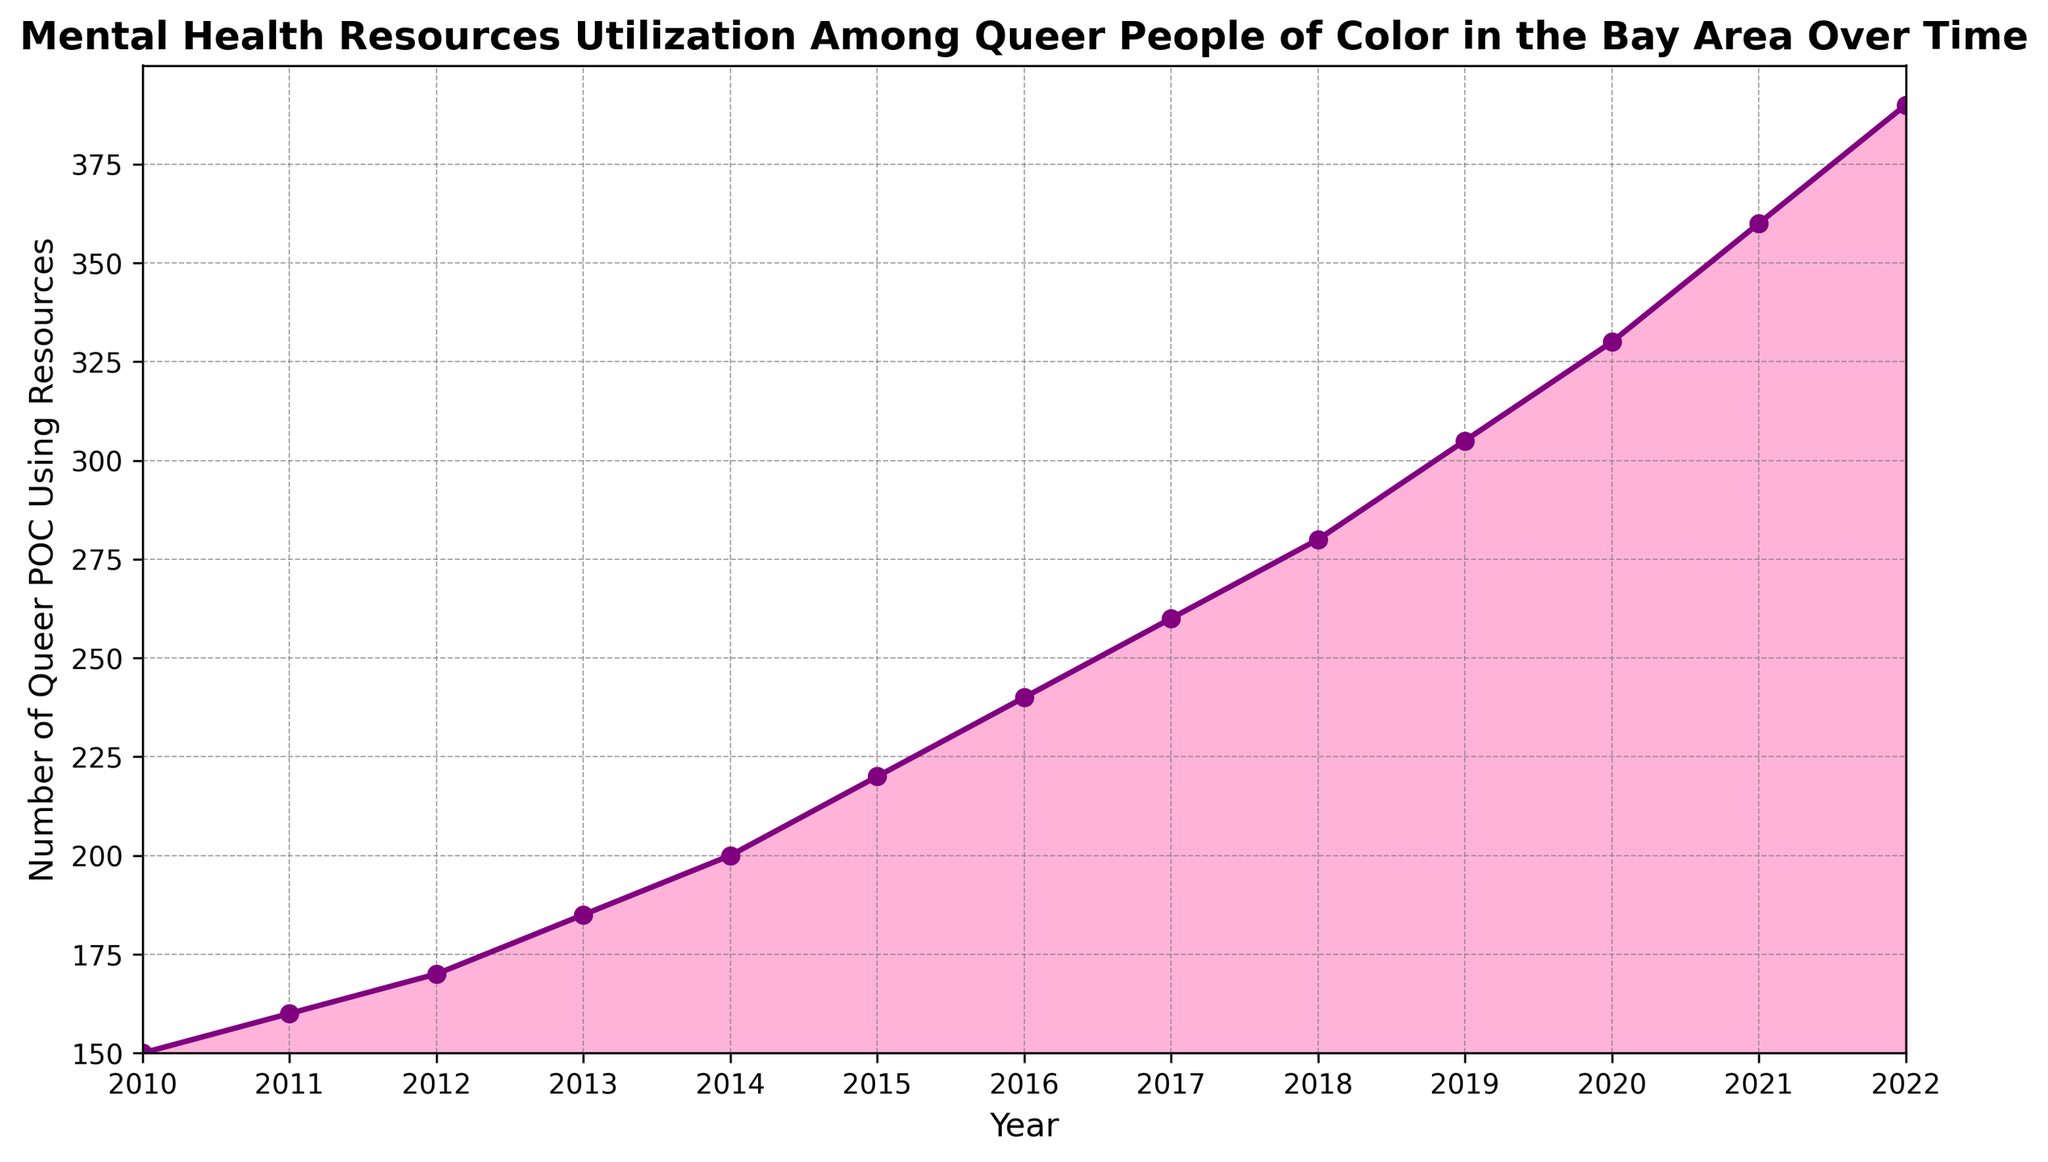What is the total increase in the number of Queer POC using mental health resources from 2010 to 2022? To find this total increase, subtract the number of users in 2010 from the number of users in 2022. So, 390 (2022) - 150 (2010) = 240.
Answer: 240 Which year saw the highest increase in the number of Queer POC using mental health resources? To determine this, observe the differences between consecutive years and identify the year with the largest increase. The biggest increase occurred between 2021 and 2022, where the number rose from 360 to 390, which is an increase of 30.
Answer: 2021-2022 How many years did it take for the number of Queer POC using resources to double from its 2010 figure? In 2010, there were 150 users. To double, it should reach 300. The year it first exceeded 300 is 2019 with 305 users. Thus, 2019 - 2010 = 9 years.
Answer: 9 years What is the average number of Queer POC using resources over the entire period from 2010 to 2022? Sum up the yearly numbers and divide by the number of years. (150+160+170+185+200+220+240+260+280+305+330+360+390) / 13 = 280.38.
Answer: 280.38 Which year had the smallest increase in the number of Queer POC using resources compared to the previous year? By comparing year-to-year differences, 2010 to 2011 had the smallest increase: 160 - 150 = 10.
Answer: 2010-2011 Was there any year where the number of Queer POC using resources remained the same as the previous year? By inspecting the plot, there is no horizontal line segment indicating such a scenario.
Answer: No How did the number of Queer POC using resources change on average each year? Calculate the average yearly increase. First, find the total increase over the period, 240, and divide it by the number of intervals (12 between 2010 and 2022). Average increase: 240 / 12 = 20.
Answer: 20 Compare the number of Queer POC using resources between 2015 and 2020. Which year had more, and by how much? In 2015, the number was 220, and in 2020, it was 330. The difference is 330 - 220 = 110.
Answer: 2020 had 110 more 